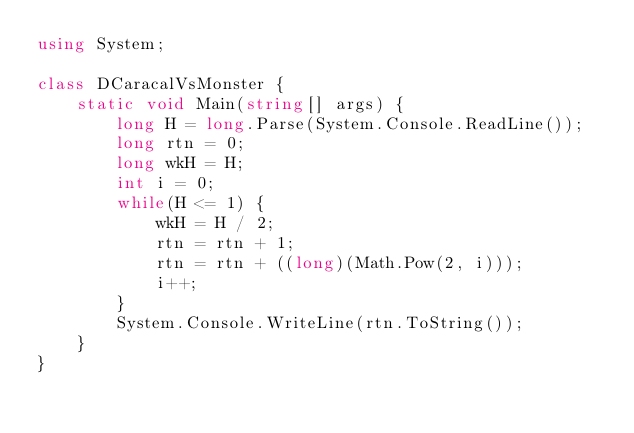<code> <loc_0><loc_0><loc_500><loc_500><_C#_>using System;

class DCaracalVsMonster {
    static void Main(string[] args) {
        long H = long.Parse(System.Console.ReadLine());
        long rtn = 0;
        long wkH = H;
        int i = 0;
        while(H <= 1) {
            wkH = H / 2;
            rtn = rtn + 1;
            rtn = rtn + ((long)(Math.Pow(2, i)));
            i++;
        }
        System.Console.WriteLine(rtn.ToString());
    }
}
</code> 